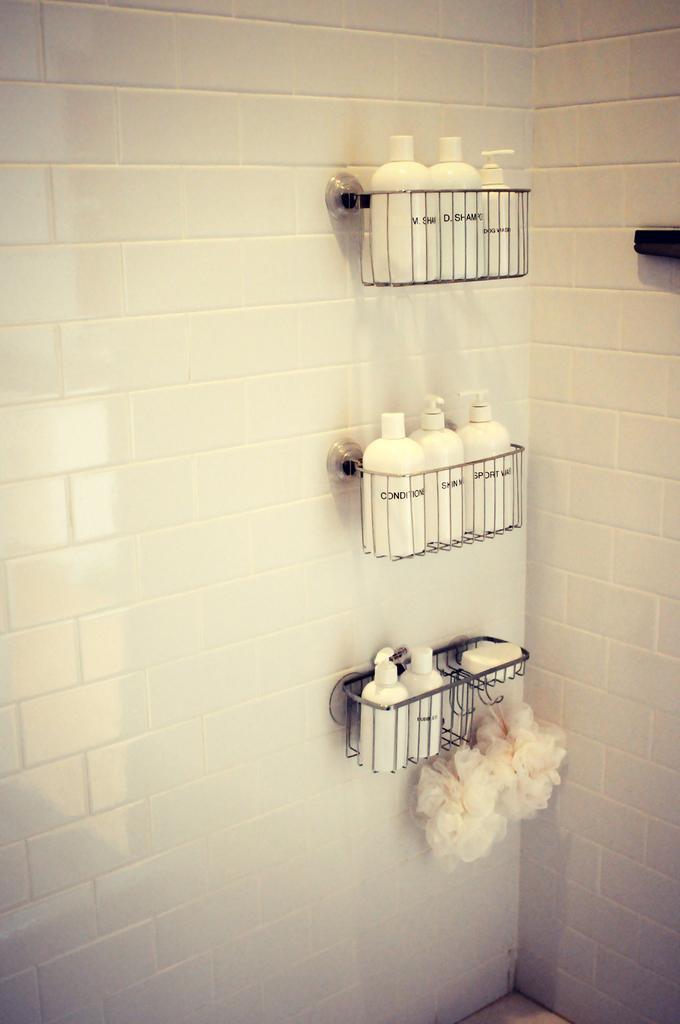Could you give a brief overview of what you see in this image? In the image we can see wall, white in color. On the wall there are metal baskets attaches. In the metal basket we can see there are bottles and we can see a scrubber. 